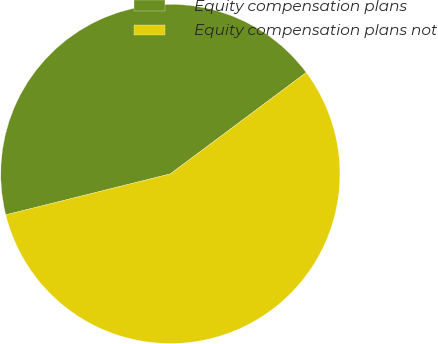Convert chart to OTSL. <chart><loc_0><loc_0><loc_500><loc_500><pie_chart><fcel>Equity compensation plans<fcel>Equity compensation plans not<nl><fcel>43.68%<fcel>56.32%<nl></chart> 